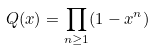Convert formula to latex. <formula><loc_0><loc_0><loc_500><loc_500>Q ( x ) = \prod _ { n \geq 1 } ( 1 - x ^ { n } )</formula> 